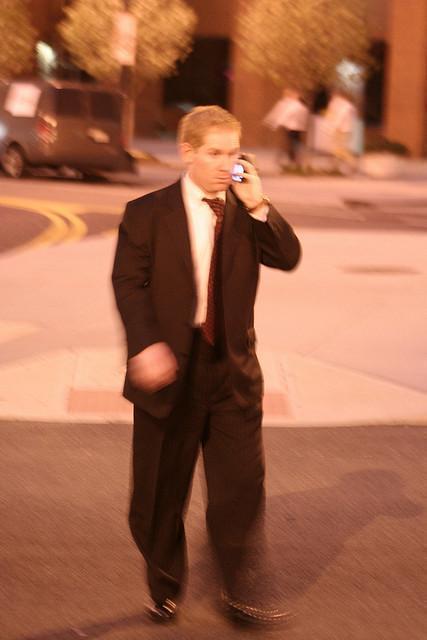How many people are in the picture?
Give a very brief answer. 2. How many pieces of broccoli are there?
Give a very brief answer. 0. 